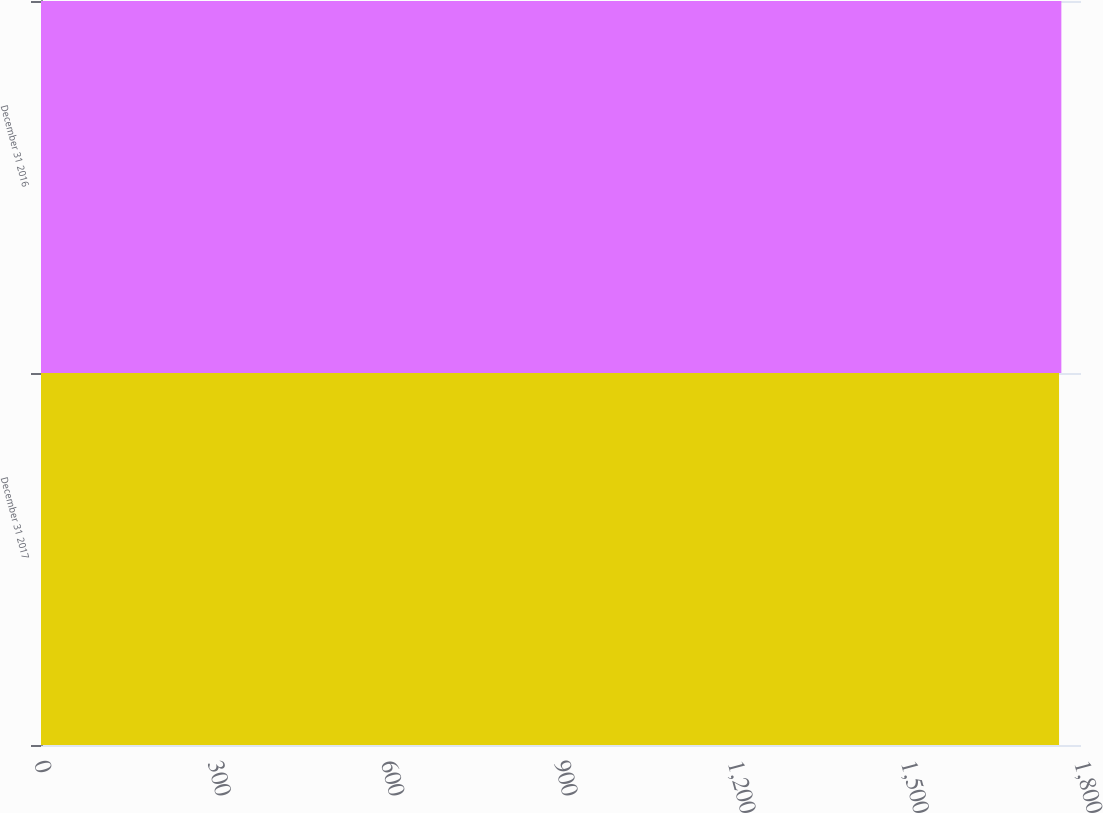Convert chart. <chart><loc_0><loc_0><loc_500><loc_500><bar_chart><fcel>December 31 2017<fcel>December 31 2016<nl><fcel>1762<fcel>1766<nl></chart> 